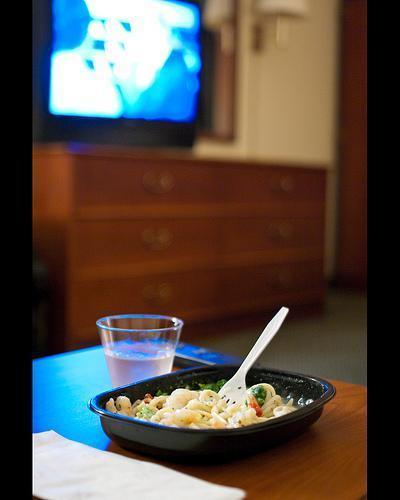How many drawers are in the dresser?
Give a very brief answer. 6. 